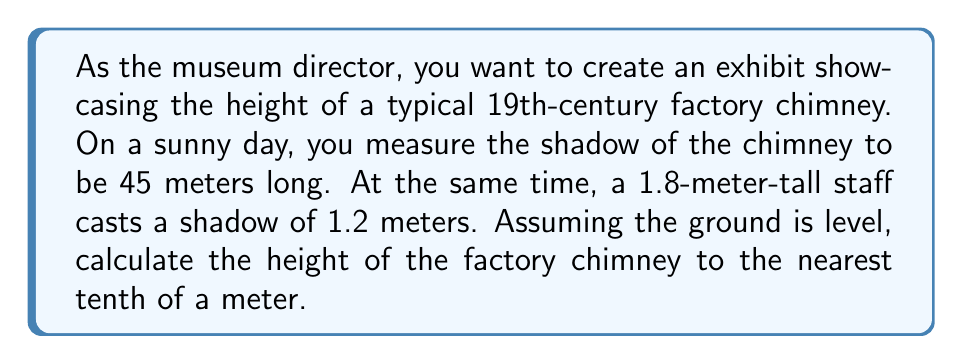Can you answer this question? To solve this problem, we'll use the concept of similar triangles and trigonometry. The sun's rays create similar triangles with the chimney and the staff.

Let's define our variables:
$h$ = height of the chimney (unknown)
$s_c$ = length of chimney's shadow = 45 m
$h_s$ = height of the staff = 1.8 m
$s_s$ = length of staff's shadow = 1.2 m

The ratio of the height to the shadow length should be the same for both the chimney and the staff:

$$\frac{h}{s_c} = \frac{h_s}{s_s}$$

We can cross-multiply to solve for $h$:

$$h \cdot s_s = s_c \cdot h_s$$
$$h = \frac{s_c \cdot h_s}{s_s}$$

Now, let's substitute the known values:

$$h = \frac{45 \cdot 1.8}{1.2}$$

Calculating:
$$h = \frac{81}{1.2} = 67.5$$

Therefore, the height of the factory chimney is 67.5 meters.

[asy]
unitsize(1cm);
pair A = (0,0), B = (9,0), C = (0,13.5), D = (1.8,0), E = (0,3.6);
draw(A--B--C--A);
draw(A--D--E--A);
label("45 m", (4.5,0), S);
label("67.5 m", (0,6.75), W);
label("1.2 m", (0.9,0), S);
label("1.8 m", (0,1.8), W);
label("Chimney", (3,5), E);
label("Staff", (0.6,1.5), E);
[/asy]
Answer: The height of the factory chimney is 67.5 meters. 